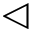Convert formula to latex. <formula><loc_0><loc_0><loc_500><loc_500>\triangleleft</formula> 